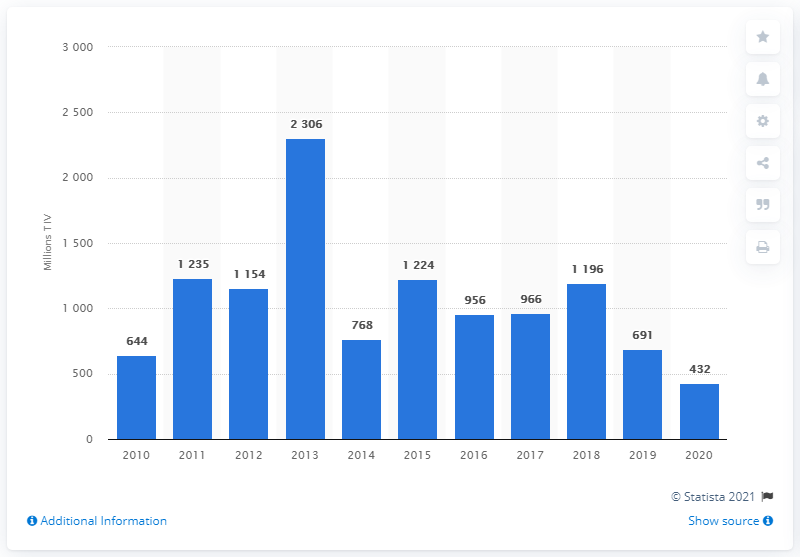What was the value of arms imports to the United Arab Emirates in 2020?
 432 